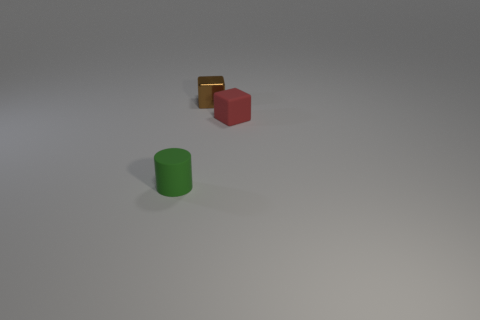Add 2 matte things. How many objects exist? 5 Subtract all cylinders. How many objects are left? 2 Add 3 tiny green matte things. How many tiny green matte things exist? 4 Subtract 0 gray cubes. How many objects are left? 3 Subtract all small brown objects. Subtract all brown shiny blocks. How many objects are left? 1 Add 3 tiny brown cubes. How many tiny brown cubes are left? 4 